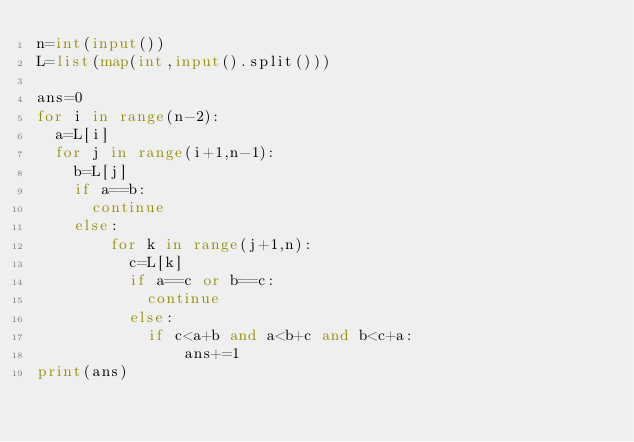<code> <loc_0><loc_0><loc_500><loc_500><_Python_>n=int(input())
L=list(map(int,input().split()))

ans=0
for i in range(n-2):
  a=L[i]
  for j in range(i+1,n-1):
    b=L[j]
    if a==b:
      continue
    else:
        for k in range(j+1,n):
          c=L[k]
          if a==c or b==c:
            continue
          else:
            if c<a+b and a<b+c and b<c+a:
                ans+=1
print(ans)
</code> 